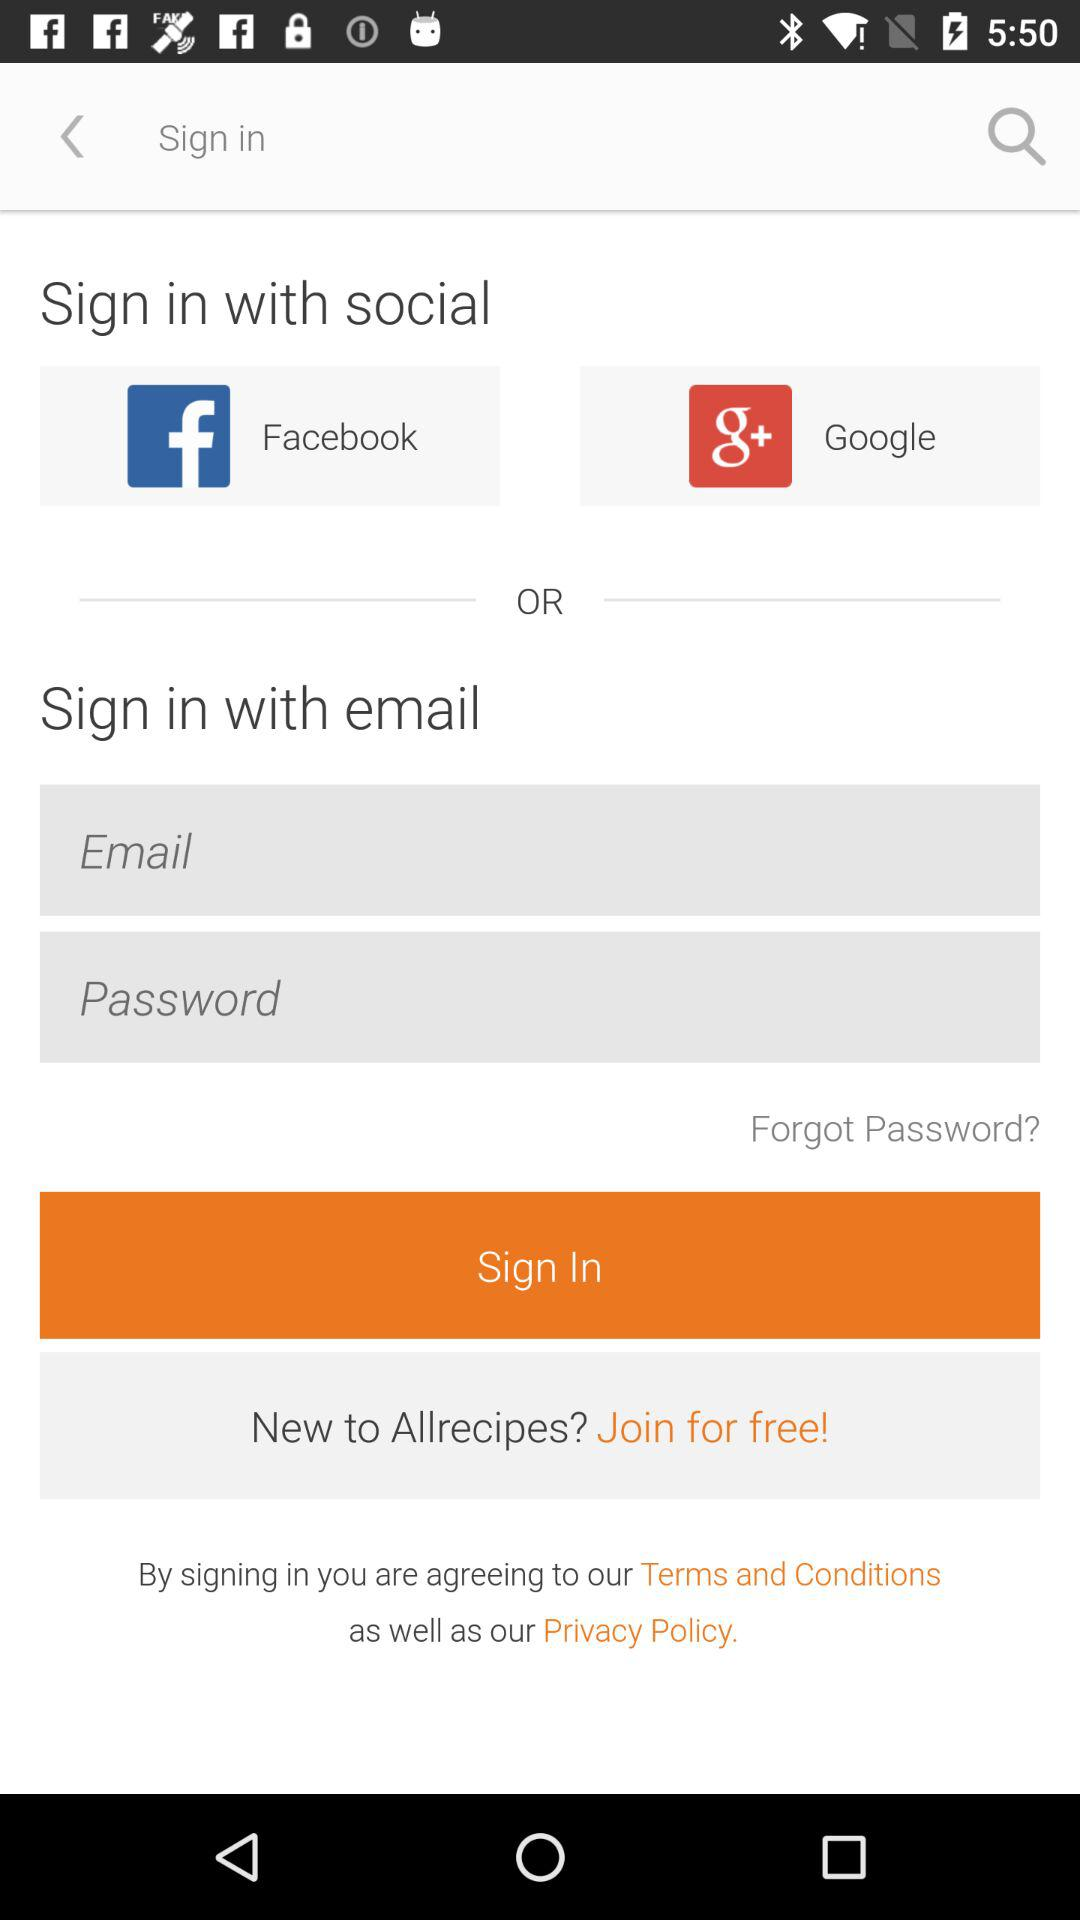How many social media options are there?
Answer the question using a single word or phrase. 2 